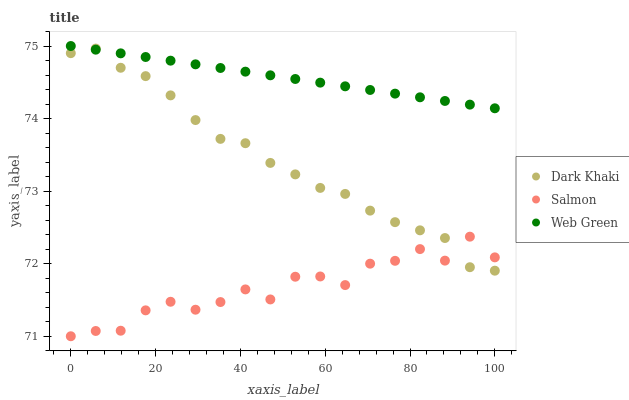Does Salmon have the minimum area under the curve?
Answer yes or no. Yes. Does Web Green have the maximum area under the curve?
Answer yes or no. Yes. Does Web Green have the minimum area under the curve?
Answer yes or no. No. Does Salmon have the maximum area under the curve?
Answer yes or no. No. Is Web Green the smoothest?
Answer yes or no. Yes. Is Salmon the roughest?
Answer yes or no. Yes. Is Salmon the smoothest?
Answer yes or no. No. Is Web Green the roughest?
Answer yes or no. No. Does Salmon have the lowest value?
Answer yes or no. Yes. Does Web Green have the lowest value?
Answer yes or no. No. Does Web Green have the highest value?
Answer yes or no. Yes. Does Salmon have the highest value?
Answer yes or no. No. Is Salmon less than Web Green?
Answer yes or no. Yes. Is Web Green greater than Salmon?
Answer yes or no. Yes. Does Dark Khaki intersect Web Green?
Answer yes or no. Yes. Is Dark Khaki less than Web Green?
Answer yes or no. No. Is Dark Khaki greater than Web Green?
Answer yes or no. No. Does Salmon intersect Web Green?
Answer yes or no. No. 